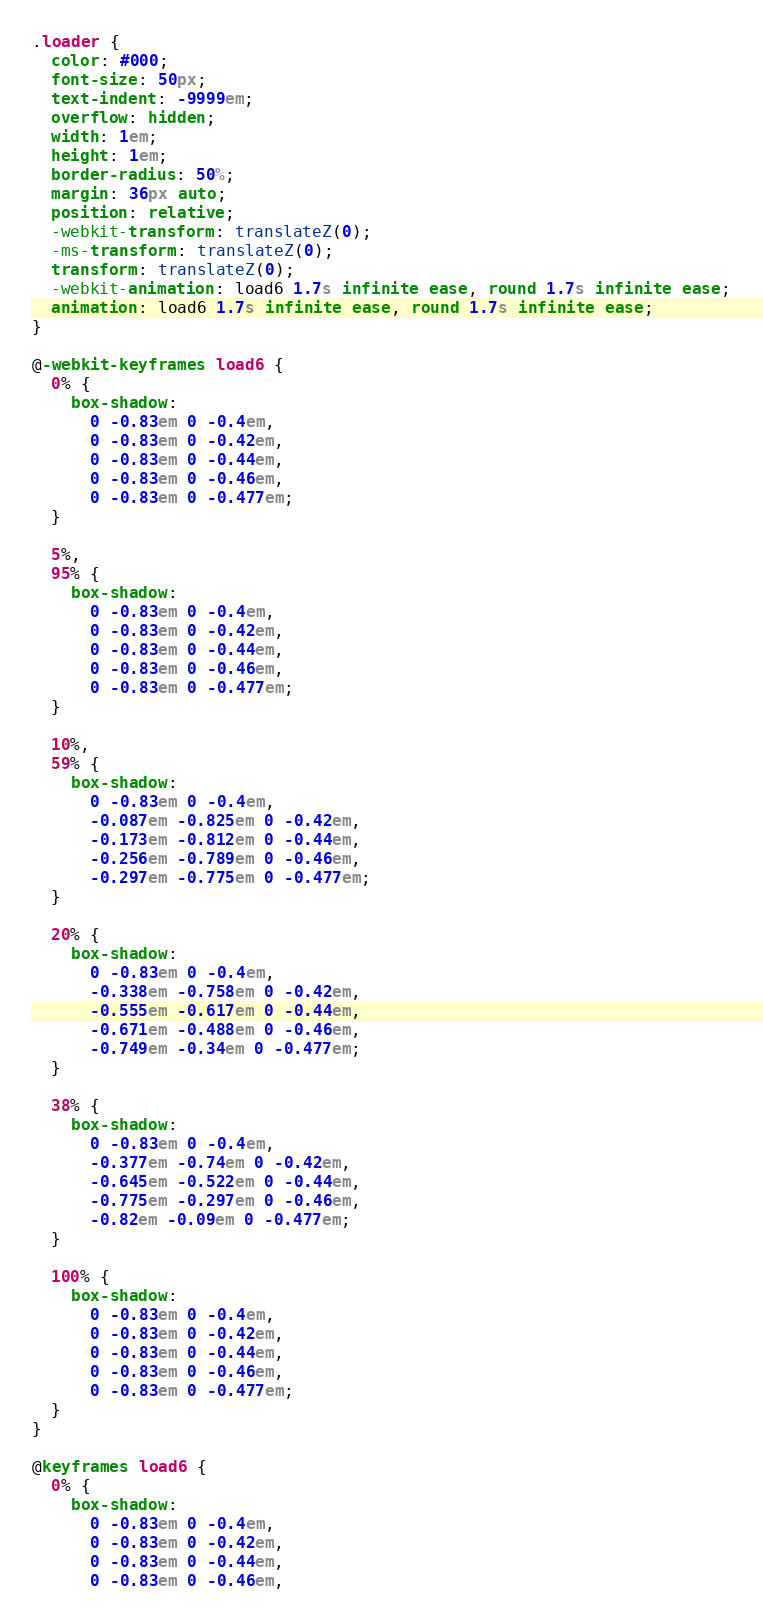<code> <loc_0><loc_0><loc_500><loc_500><_CSS_>.loader {
  color: #000;
  font-size: 50px;
  text-indent: -9999em;
  overflow: hidden;
  width: 1em;
  height: 1em;
  border-radius: 50%;
  margin: 36px auto;
  position: relative;
  -webkit-transform: translateZ(0);
  -ms-transform: translateZ(0);
  transform: translateZ(0);
  -webkit-animation: load6 1.7s infinite ease, round 1.7s infinite ease;
  animation: load6 1.7s infinite ease, round 1.7s infinite ease;
}

@-webkit-keyframes load6 {
  0% {
    box-shadow:
      0 -0.83em 0 -0.4em,
      0 -0.83em 0 -0.42em,
      0 -0.83em 0 -0.44em,
      0 -0.83em 0 -0.46em,
      0 -0.83em 0 -0.477em;
  }

  5%,
  95% {
    box-shadow:
      0 -0.83em 0 -0.4em,
      0 -0.83em 0 -0.42em,
      0 -0.83em 0 -0.44em,
      0 -0.83em 0 -0.46em,
      0 -0.83em 0 -0.477em;
  }

  10%,
  59% {
    box-shadow:
      0 -0.83em 0 -0.4em,
      -0.087em -0.825em 0 -0.42em,
      -0.173em -0.812em 0 -0.44em,
      -0.256em -0.789em 0 -0.46em,
      -0.297em -0.775em 0 -0.477em;
  }

  20% {
    box-shadow:
      0 -0.83em 0 -0.4em,
      -0.338em -0.758em 0 -0.42em,
      -0.555em -0.617em 0 -0.44em,
      -0.671em -0.488em 0 -0.46em,
      -0.749em -0.34em 0 -0.477em;
  }

  38% {
    box-shadow:
      0 -0.83em 0 -0.4em,
      -0.377em -0.74em 0 -0.42em,
      -0.645em -0.522em 0 -0.44em,
      -0.775em -0.297em 0 -0.46em,
      -0.82em -0.09em 0 -0.477em;
  }

  100% {
    box-shadow:
      0 -0.83em 0 -0.4em,
      0 -0.83em 0 -0.42em,
      0 -0.83em 0 -0.44em,
      0 -0.83em 0 -0.46em,
      0 -0.83em 0 -0.477em;
  }
}

@keyframes load6 {
  0% {
    box-shadow:
      0 -0.83em 0 -0.4em,
      0 -0.83em 0 -0.42em,
      0 -0.83em 0 -0.44em,
      0 -0.83em 0 -0.46em,</code> 